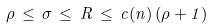<formula> <loc_0><loc_0><loc_500><loc_500>\rho \, \leq \, \sigma \, \leq \, R \, \leq \, c ( n ) \, ( \rho + 1 )</formula> 